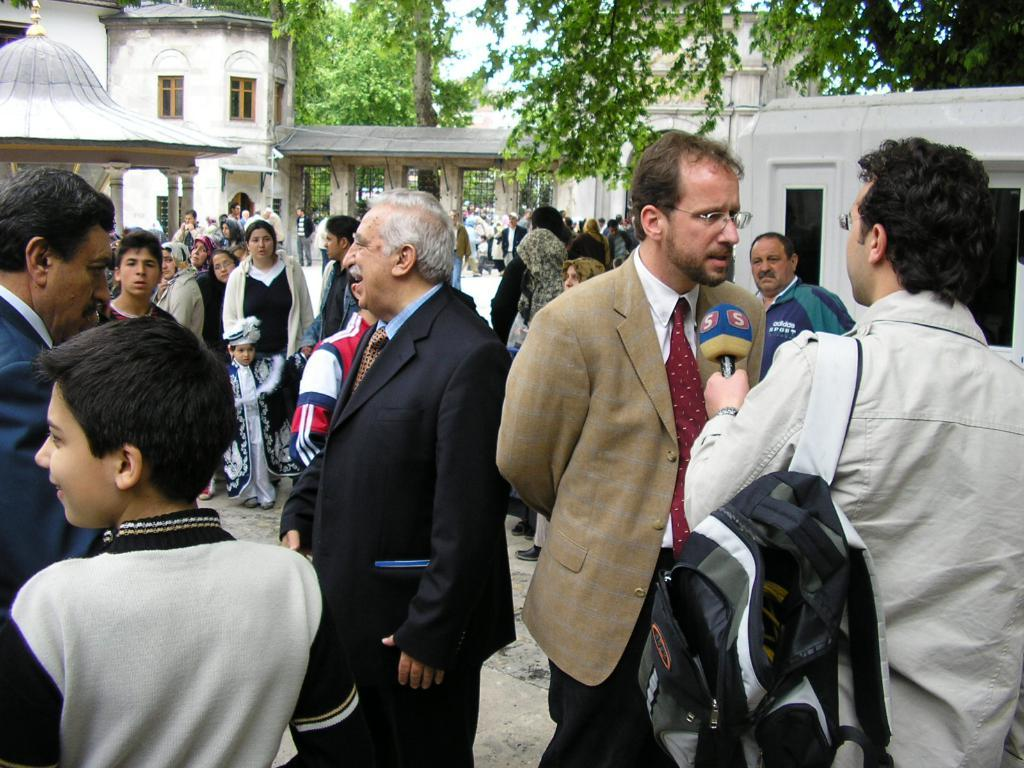What is the main subject of the image? The main subject of the image is a group of people. Where are the people located in the image? The group of people is in the middle of the image. What can be seen in the background of the image? There are buildings and trees in the background of the image. What type of cork can be seen floating in the water in the image? There is no water or cork present in the image; it features a group of people in the middle with buildings and trees in the background. 